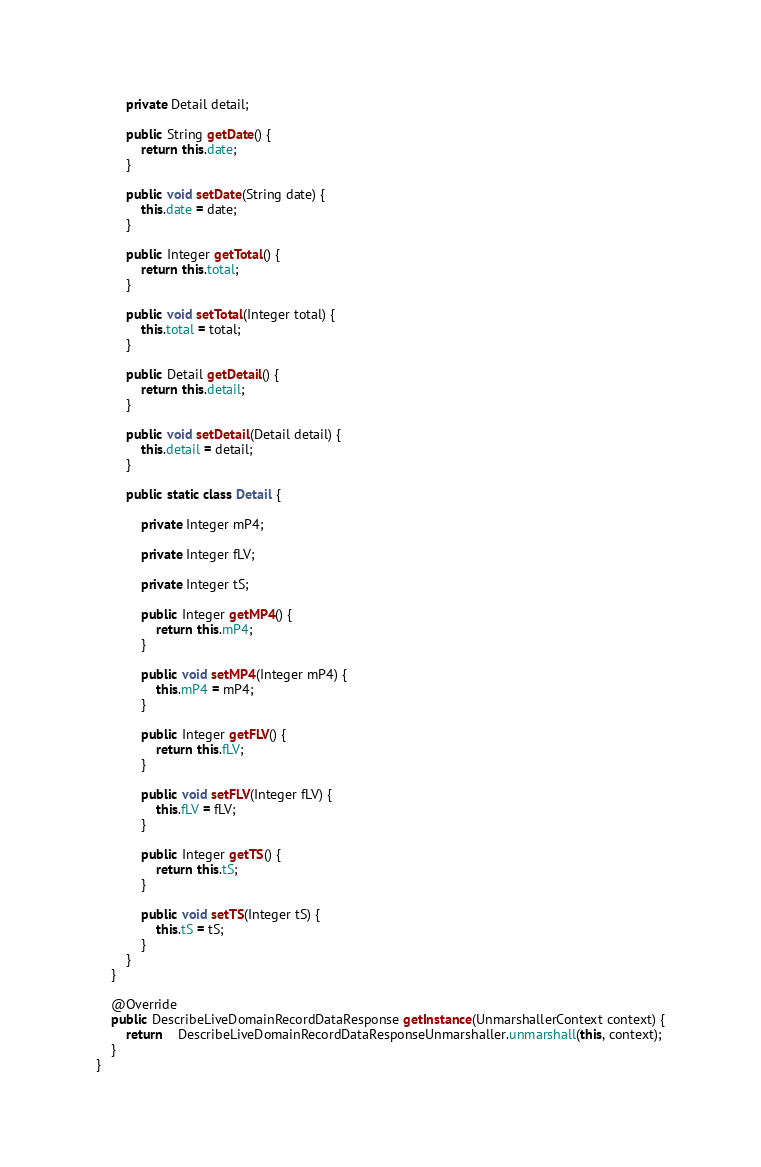Convert code to text. <code><loc_0><loc_0><loc_500><loc_500><_Java_>
		private Detail detail;

		public String getDate() {
			return this.date;
		}

		public void setDate(String date) {
			this.date = date;
		}

		public Integer getTotal() {
			return this.total;
		}

		public void setTotal(Integer total) {
			this.total = total;
		}

		public Detail getDetail() {
			return this.detail;
		}

		public void setDetail(Detail detail) {
			this.detail = detail;
		}

		public static class Detail {

			private Integer mP4;

			private Integer fLV;

			private Integer tS;

			public Integer getMP4() {
				return this.mP4;
			}

			public void setMP4(Integer mP4) {
				this.mP4 = mP4;
			}

			public Integer getFLV() {
				return this.fLV;
			}

			public void setFLV(Integer fLV) {
				this.fLV = fLV;
			}

			public Integer getTS() {
				return this.tS;
			}

			public void setTS(Integer tS) {
				this.tS = tS;
			}
		}
	}

	@Override
	public DescribeLiveDomainRecordDataResponse getInstance(UnmarshallerContext context) {
		return	DescribeLiveDomainRecordDataResponseUnmarshaller.unmarshall(this, context);
	}
}
</code> 